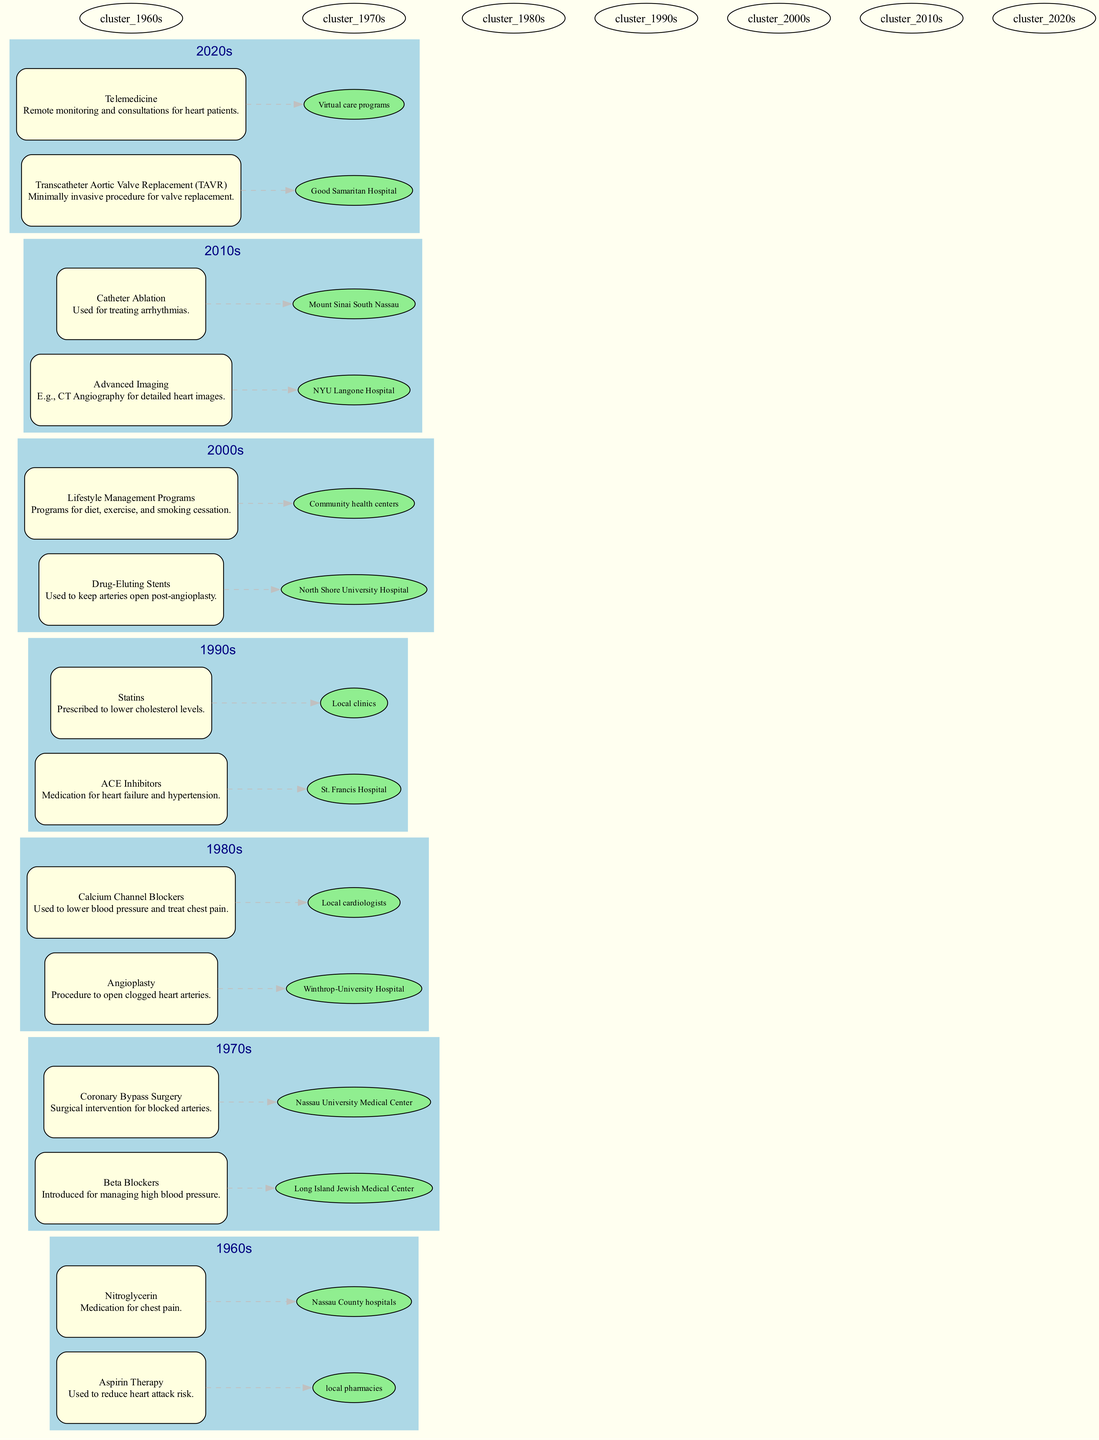What are common treatments for cardiovascular issues in the 1980s? In the diagram, the treatments listed under the 1980s section are "Angioplasty" and "Calcium Channel Blockers."
Answer: Angioplasty, Calcium Channel Blockers Which treatment was introduced for managing high blood pressure in the 1970s? The diagram shows that "Beta Blockers" were introduced for managing high blood pressure in the 1970s.
Answer: Beta Blockers What related entity is associated with Statins? The diagram states that Statins are related to "Local clinics."
Answer: Local clinics How many treatments are listed for the decade of the 1990s? There are two treatments listed for the 1990s: "ACE Inhibitors" and "Statins," making a total of two.
Answer: 2 What is a minimally invasive procedure introduced in the 2020s? The diagram indicates that "Transcatheter Aortic Valve Replacement (TAVR)" is a minimally invasive procedure introduced in the 2020s.
Answer: Transcatheter Aortic Valve Replacement (TAVR) Which treatment is related to community health centers? According to the diagram, "Lifestyle Management Programs" are related to community health centers.
Answer: Lifestyle Management Programs What type of technology does "Telemedicine" represent? The diagram categorizes "Telemedicine" as representing remote monitoring and consultations for heart patients.
Answer: Remote monitoring and consultations What decade saw the introduction of Drug-Eluting Stents? The diagram shows that Drug-Eluting Stents were introduced in the 2000s.
Answer: 2000s How did treatments evolve from the 1960s to the 2010s? The diagram highlights a progression from basic medications like Aspirin and Nitroglycerin in the 1960s to advanced techniques like Catheter Ablation and Advanced Imaging in the 2010s, indicating an evolution in both technology and treatment complexity.
Answer: From medications to advanced techniques 